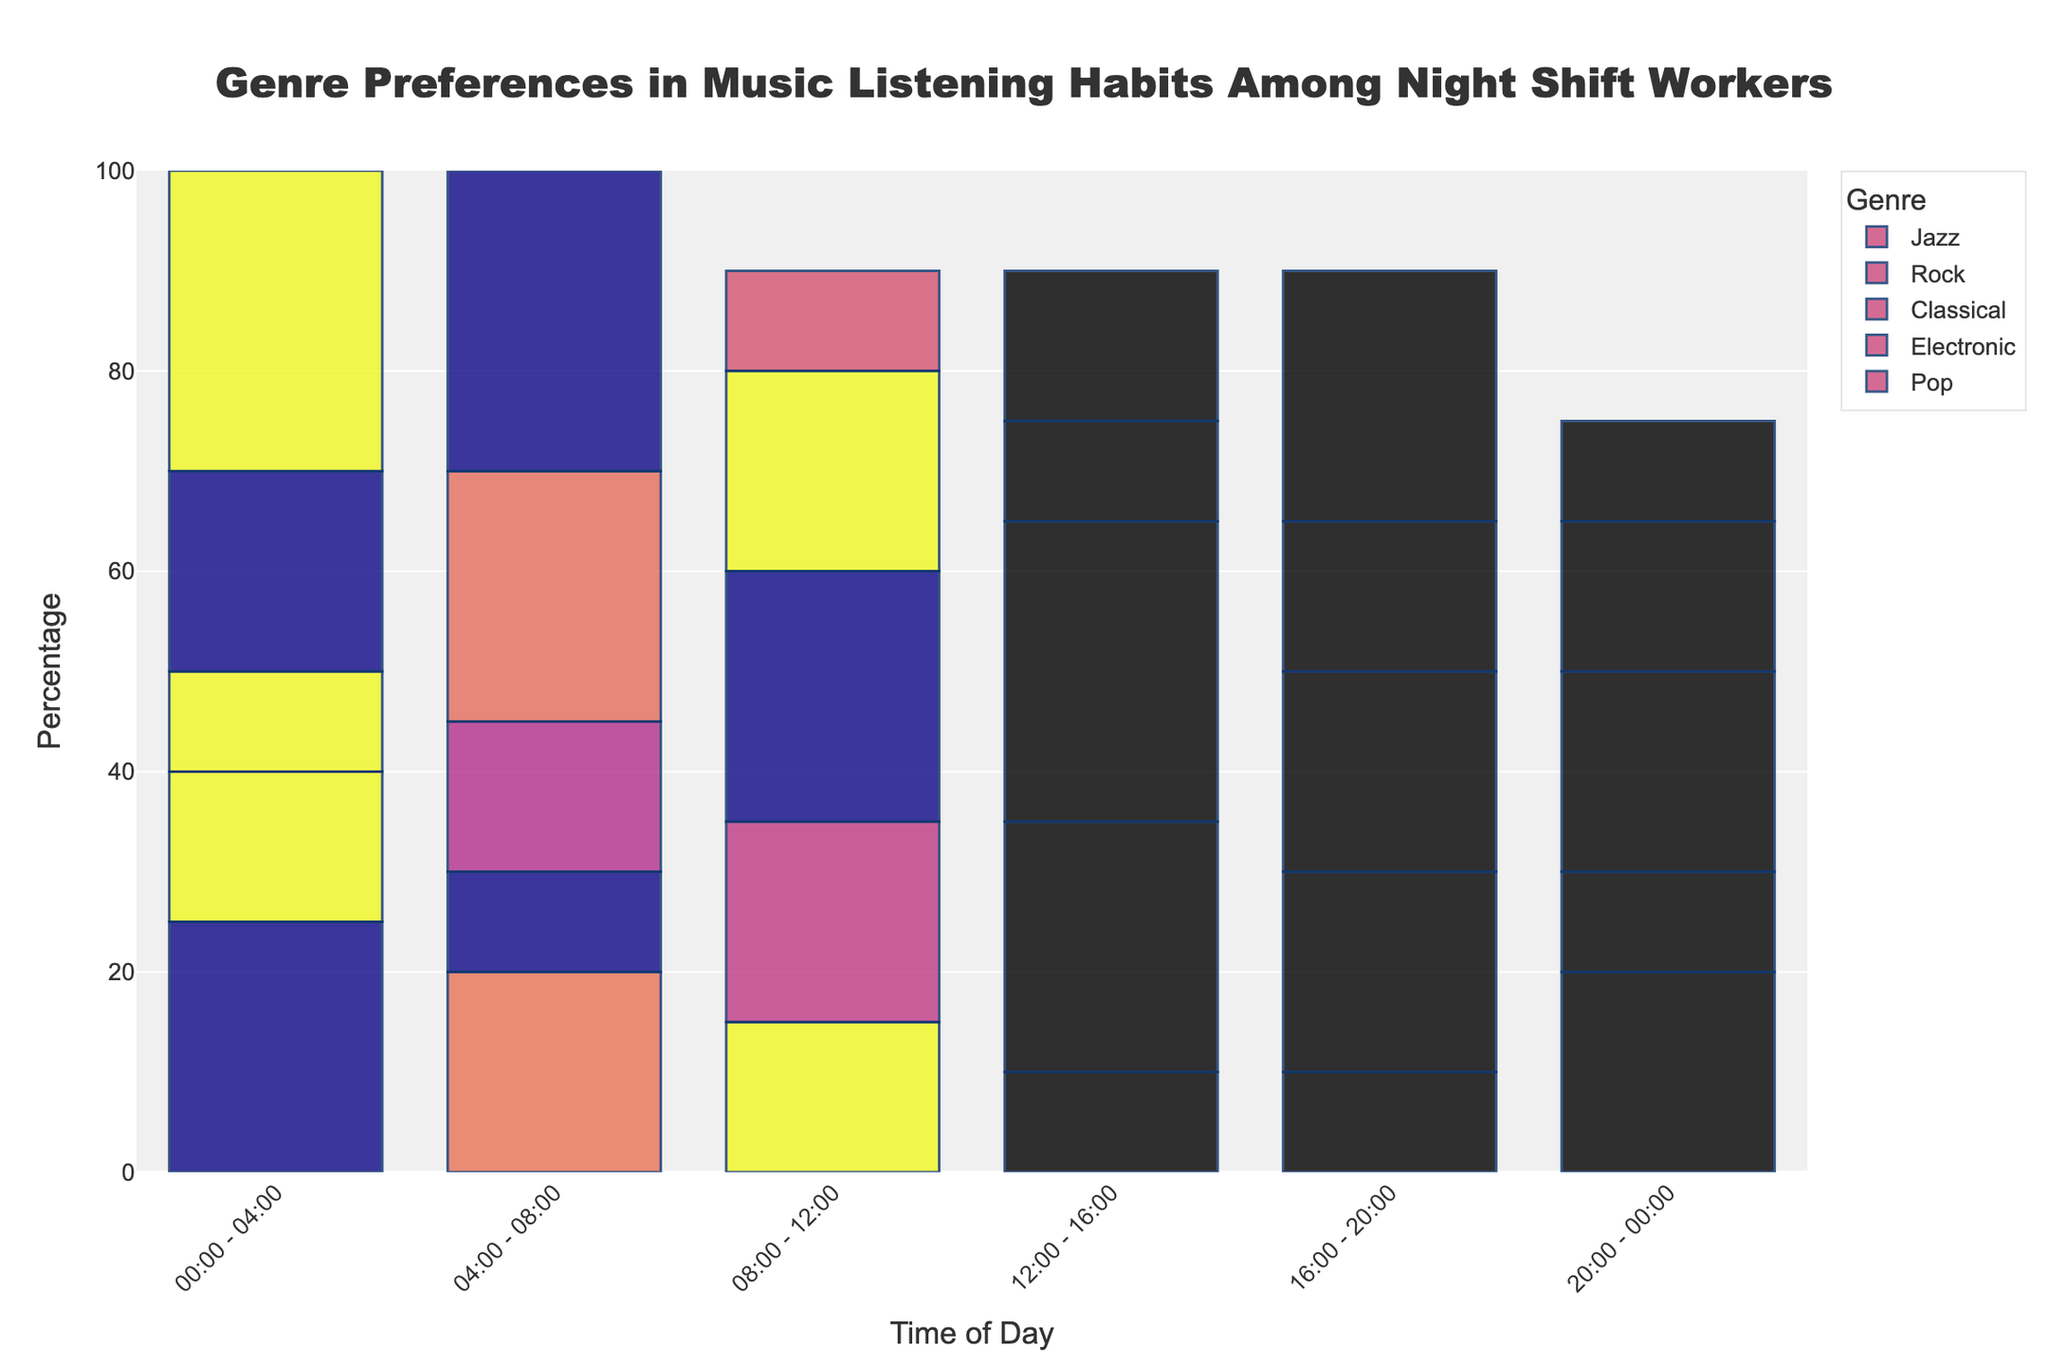Which genre is most preferred from 00:00 - 04:00? Look at the tallest bar in the 00:00 - 04:00 time slot to find the genre with the highest percentage. In this case, the tallest bar is for Pop at 30%.
Answer: Pop Which period has the highest preference for Classical music? Identify the time slot with the highest bar for Classical music. From the figure, the 12:00 - 16:00 slot has the highest bar at 30%.
Answer: 12:00 - 16:00 What is the combined percentage of Electronic and Jazz from 04:00 - 08:00? The Electronic bar is at 25% and the Jazz bar is at 20% for the 04:00 - 08:00 slot. Their sum is 25% + 20% = 45%.
Answer: 45% During what time period is Rock music less preferred than Electronic music but more preferred than Jazz? Identify the time slots where the Rock bar is shorter than the Electronic bar but taller than the Jazz bar. The 16:00 - 20:00 slot fits these criteria with Rock at 20%, Electronic at 15%, and Jazz at 10%.
Answer: 16:00 - 20:00 What is the range in preference percentages for Pop across all time periods? Determine the difference between the maximum and minimum percentages for Pop. The highest is 30% (00:00 - 04:00 and 04:00 - 08:00) and the lowest is 10% (08:00 - 12:00 and 20:00 - 00:00), making the range 30% - 10% = 20%.
Answer: 20% Which time slot sees the highest and lowest overall music preference for night shift workers? Sum the bars for all genres in each time slot and find the one with the highest and lowest total. The highest is 20:00 - 00:00 with a total of 85%, and the lowest is 08:00 - 12:00 with a total of 90%. Thus, the lowest is the period from 12:00-16:00.
Answer: Highest: 00:00 - 04:00, Lowest: 12:00-16:00 Is there any time period where all genres are equally preferred? Check each time slot to see if the bars for all genres are the same height. There is no time slot where all genres have the same percentage.
Answer: No 